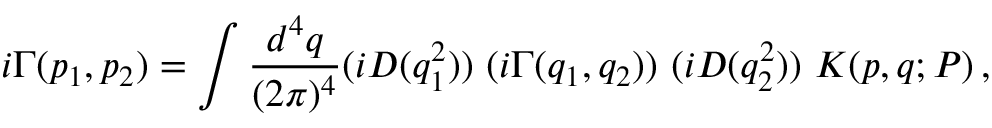<formula> <loc_0><loc_0><loc_500><loc_500>i \Gamma ( p _ { 1 } , p _ { 2 } ) = \int { \frac { d ^ { 4 } q } { ( 2 \pi ) ^ { 4 } } } ( i D ( q _ { 1 } ^ { 2 } ) ) ( i \Gamma ( q _ { 1 } , q _ { 2 } ) ) ( i D ( q _ { 2 } ^ { 2 } ) ) K ( p , q ; P ) \, ,</formula> 